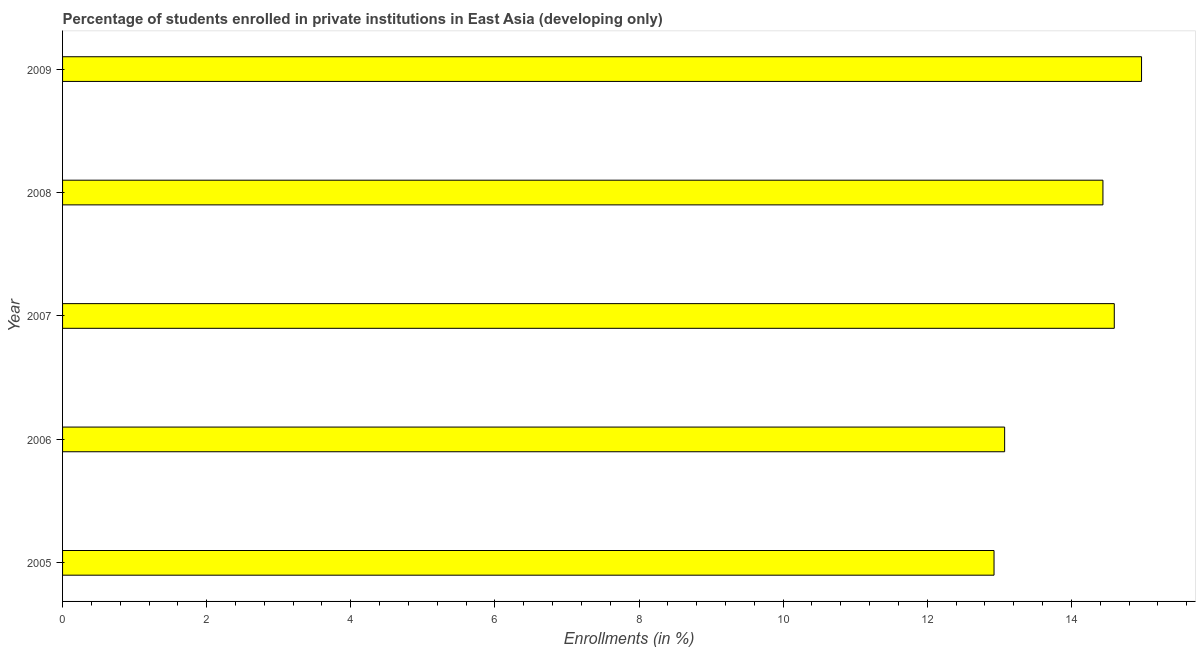What is the title of the graph?
Your answer should be very brief. Percentage of students enrolled in private institutions in East Asia (developing only). What is the label or title of the X-axis?
Your response must be concise. Enrollments (in %). What is the label or title of the Y-axis?
Your answer should be compact. Year. What is the enrollments in private institutions in 2005?
Your answer should be compact. 12.93. Across all years, what is the maximum enrollments in private institutions?
Offer a very short reply. 14.97. Across all years, what is the minimum enrollments in private institutions?
Offer a very short reply. 12.93. In which year was the enrollments in private institutions maximum?
Give a very brief answer. 2009. In which year was the enrollments in private institutions minimum?
Your answer should be compact. 2005. What is the sum of the enrollments in private institutions?
Offer a very short reply. 70.01. What is the difference between the enrollments in private institutions in 2006 and 2008?
Your answer should be very brief. -1.36. What is the average enrollments in private institutions per year?
Your answer should be compact. 14. What is the median enrollments in private institutions?
Your response must be concise. 14.44. What is the ratio of the enrollments in private institutions in 2006 to that in 2009?
Keep it short and to the point. 0.87. Is the difference between the enrollments in private institutions in 2006 and 2007 greater than the difference between any two years?
Offer a very short reply. No. What is the difference between the highest and the second highest enrollments in private institutions?
Your response must be concise. 0.38. What is the difference between the highest and the lowest enrollments in private institutions?
Offer a very short reply. 2.05. Are all the bars in the graph horizontal?
Keep it short and to the point. Yes. How many years are there in the graph?
Your response must be concise. 5. What is the difference between two consecutive major ticks on the X-axis?
Your answer should be compact. 2. Are the values on the major ticks of X-axis written in scientific E-notation?
Your answer should be compact. No. What is the Enrollments (in %) of 2005?
Provide a short and direct response. 12.93. What is the Enrollments (in %) of 2006?
Ensure brevity in your answer.  13.07. What is the Enrollments (in %) of 2007?
Your response must be concise. 14.6. What is the Enrollments (in %) in 2008?
Provide a succinct answer. 14.44. What is the Enrollments (in %) of 2009?
Your answer should be very brief. 14.97. What is the difference between the Enrollments (in %) in 2005 and 2006?
Keep it short and to the point. -0.15. What is the difference between the Enrollments (in %) in 2005 and 2007?
Your answer should be very brief. -1.67. What is the difference between the Enrollments (in %) in 2005 and 2008?
Your response must be concise. -1.51. What is the difference between the Enrollments (in %) in 2005 and 2009?
Your answer should be very brief. -2.05. What is the difference between the Enrollments (in %) in 2006 and 2007?
Your answer should be very brief. -1.52. What is the difference between the Enrollments (in %) in 2006 and 2008?
Your answer should be very brief. -1.36. What is the difference between the Enrollments (in %) in 2006 and 2009?
Offer a very short reply. -1.9. What is the difference between the Enrollments (in %) in 2007 and 2008?
Your response must be concise. 0.16. What is the difference between the Enrollments (in %) in 2007 and 2009?
Your response must be concise. -0.38. What is the difference between the Enrollments (in %) in 2008 and 2009?
Keep it short and to the point. -0.54. What is the ratio of the Enrollments (in %) in 2005 to that in 2007?
Your answer should be very brief. 0.89. What is the ratio of the Enrollments (in %) in 2005 to that in 2008?
Your response must be concise. 0.9. What is the ratio of the Enrollments (in %) in 2005 to that in 2009?
Provide a succinct answer. 0.86. What is the ratio of the Enrollments (in %) in 2006 to that in 2007?
Your answer should be compact. 0.9. What is the ratio of the Enrollments (in %) in 2006 to that in 2008?
Provide a short and direct response. 0.91. What is the ratio of the Enrollments (in %) in 2006 to that in 2009?
Keep it short and to the point. 0.87. What is the ratio of the Enrollments (in %) in 2007 to that in 2008?
Offer a terse response. 1.01. 